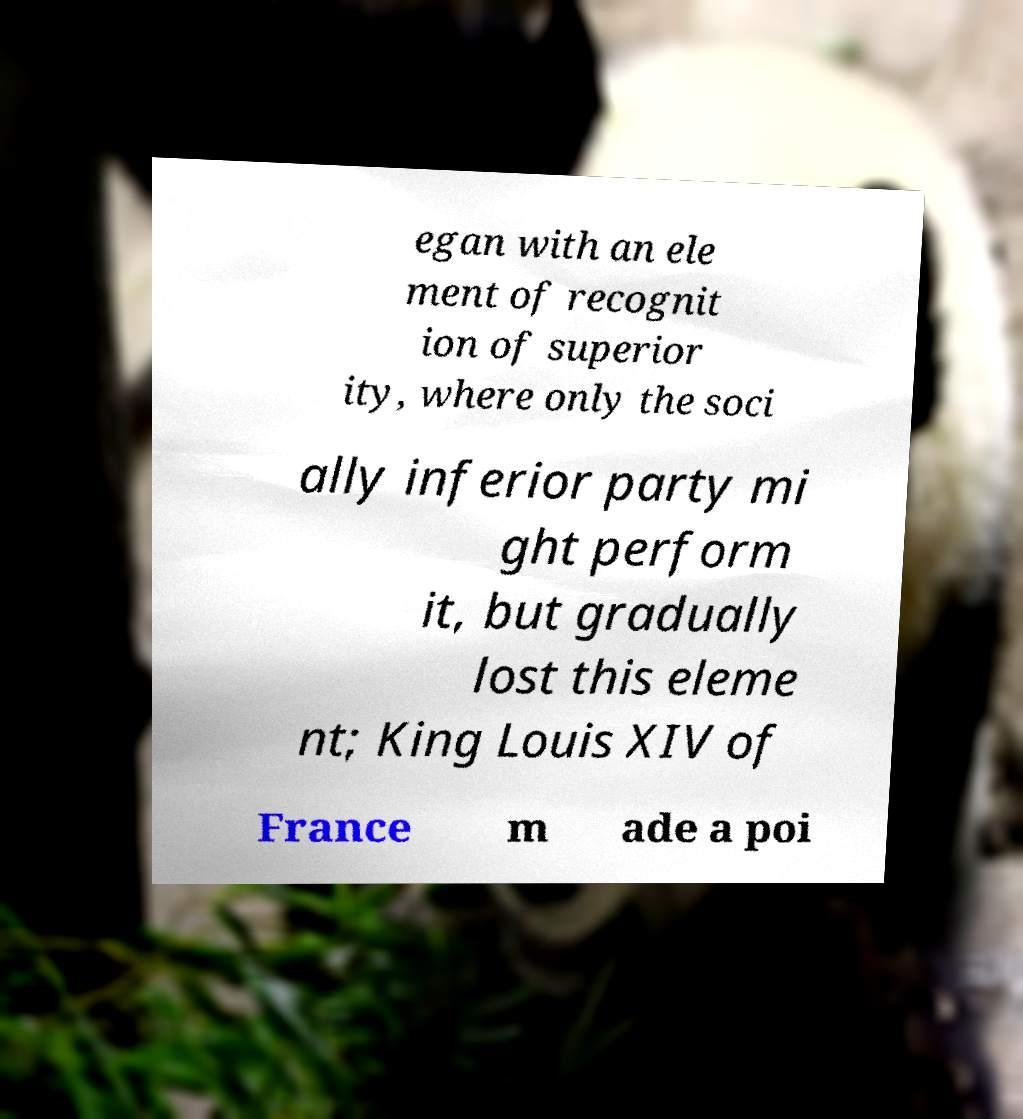What messages or text are displayed in this image? I need them in a readable, typed format. egan with an ele ment of recognit ion of superior ity, where only the soci ally inferior party mi ght perform it, but gradually lost this eleme nt; King Louis XIV of France m ade a poi 